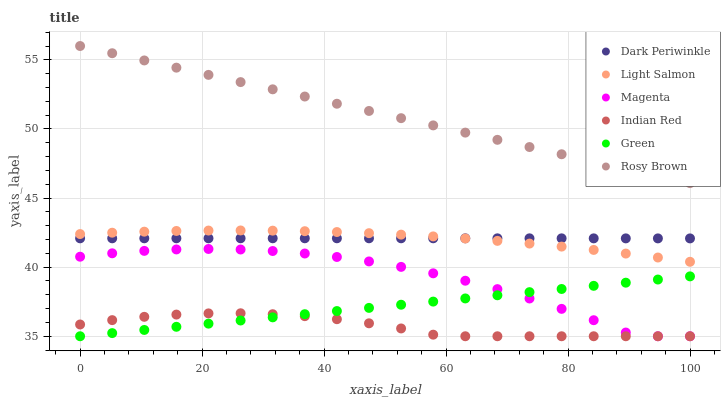Does Indian Red have the minimum area under the curve?
Answer yes or no. Yes. Does Rosy Brown have the maximum area under the curve?
Answer yes or no. Yes. Does Green have the minimum area under the curve?
Answer yes or no. No. Does Green have the maximum area under the curve?
Answer yes or no. No. Is Green the smoothest?
Answer yes or no. Yes. Is Magenta the roughest?
Answer yes or no. Yes. Is Rosy Brown the smoothest?
Answer yes or no. No. Is Rosy Brown the roughest?
Answer yes or no. No. Does Green have the lowest value?
Answer yes or no. Yes. Does Rosy Brown have the lowest value?
Answer yes or no. No. Does Rosy Brown have the highest value?
Answer yes or no. Yes. Does Green have the highest value?
Answer yes or no. No. Is Indian Red less than Dark Periwinkle?
Answer yes or no. Yes. Is Dark Periwinkle greater than Indian Red?
Answer yes or no. Yes. Does Indian Red intersect Magenta?
Answer yes or no. Yes. Is Indian Red less than Magenta?
Answer yes or no. No. Is Indian Red greater than Magenta?
Answer yes or no. No. Does Indian Red intersect Dark Periwinkle?
Answer yes or no. No. 